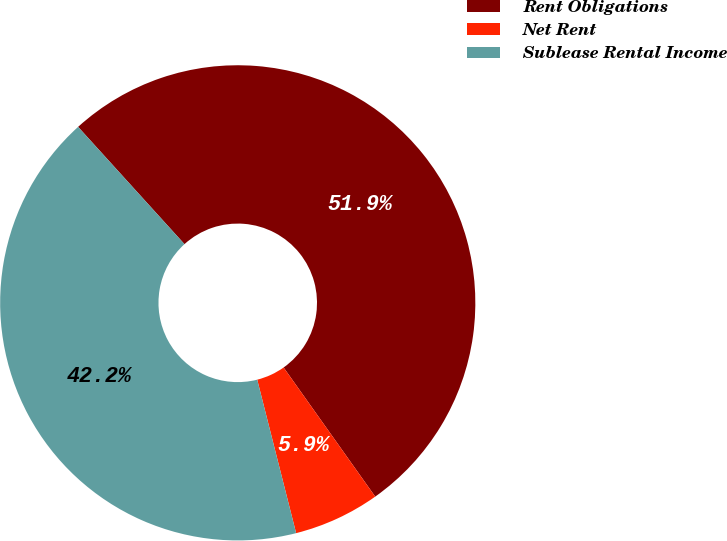<chart> <loc_0><loc_0><loc_500><loc_500><pie_chart><fcel>Rent Obligations<fcel>Net Rent<fcel>Sublease Rental Income<nl><fcel>51.91%<fcel>5.87%<fcel>42.23%<nl></chart> 